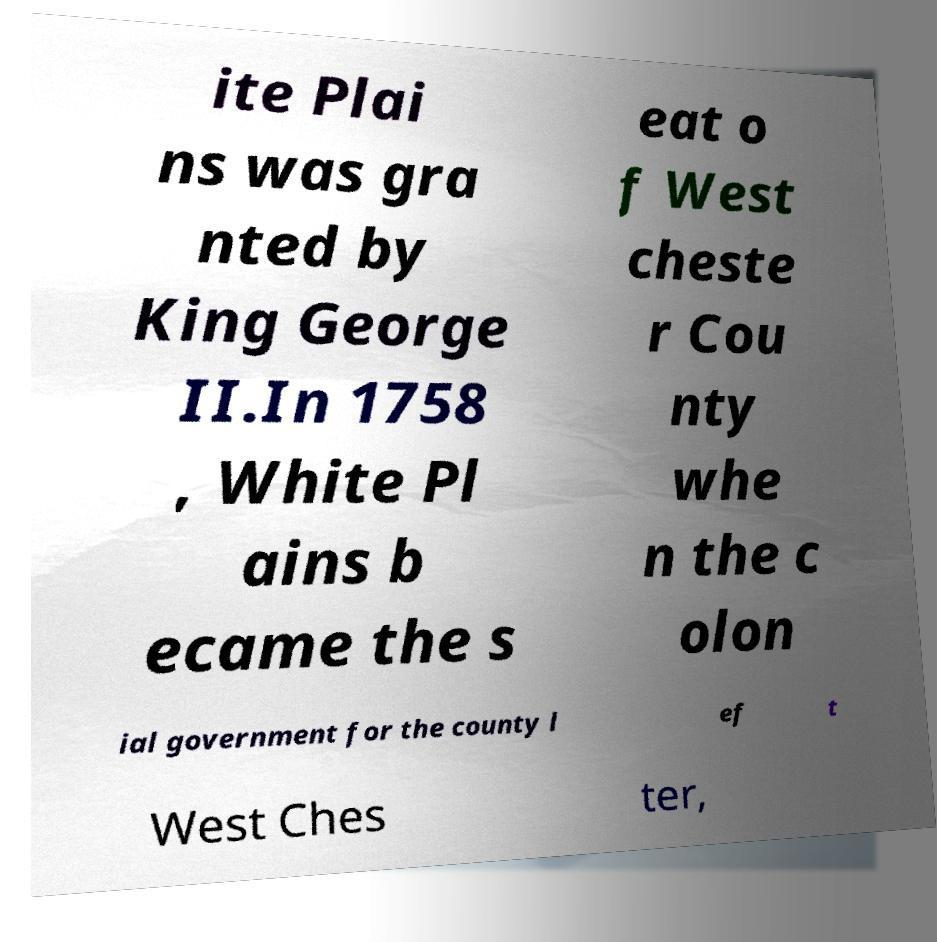What messages or text are displayed in this image? I need them in a readable, typed format. ite Plai ns was gra nted by King George II.In 1758 , White Pl ains b ecame the s eat o f West cheste r Cou nty whe n the c olon ial government for the county l ef t West Ches ter, 